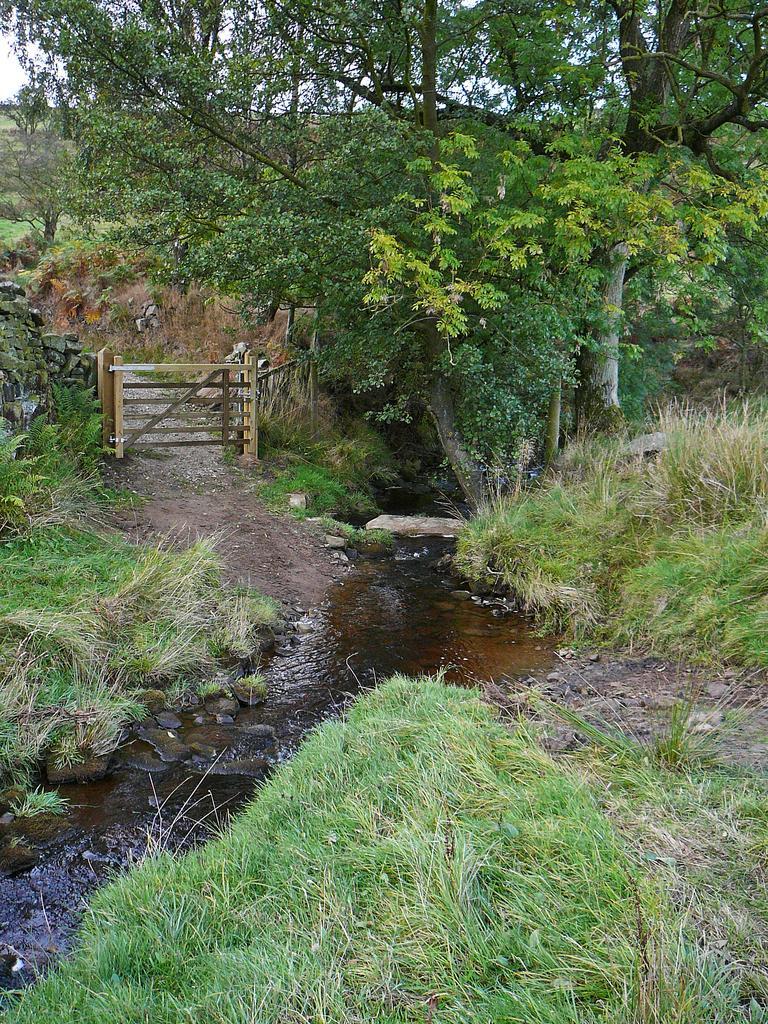Describe this image in one or two sentences. In the image there is a greenery and the water is flowing in between the grass surface, on the left side there is a wooden fence. 